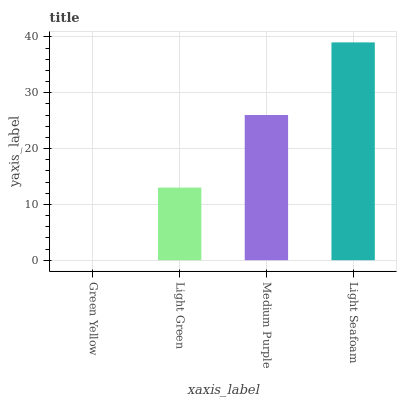Is Light Green the minimum?
Answer yes or no. No. Is Light Green the maximum?
Answer yes or no. No. Is Light Green greater than Green Yellow?
Answer yes or no. Yes. Is Green Yellow less than Light Green?
Answer yes or no. Yes. Is Green Yellow greater than Light Green?
Answer yes or no. No. Is Light Green less than Green Yellow?
Answer yes or no. No. Is Medium Purple the high median?
Answer yes or no. Yes. Is Light Green the low median?
Answer yes or no. Yes. Is Green Yellow the high median?
Answer yes or no. No. Is Light Seafoam the low median?
Answer yes or no. No. 